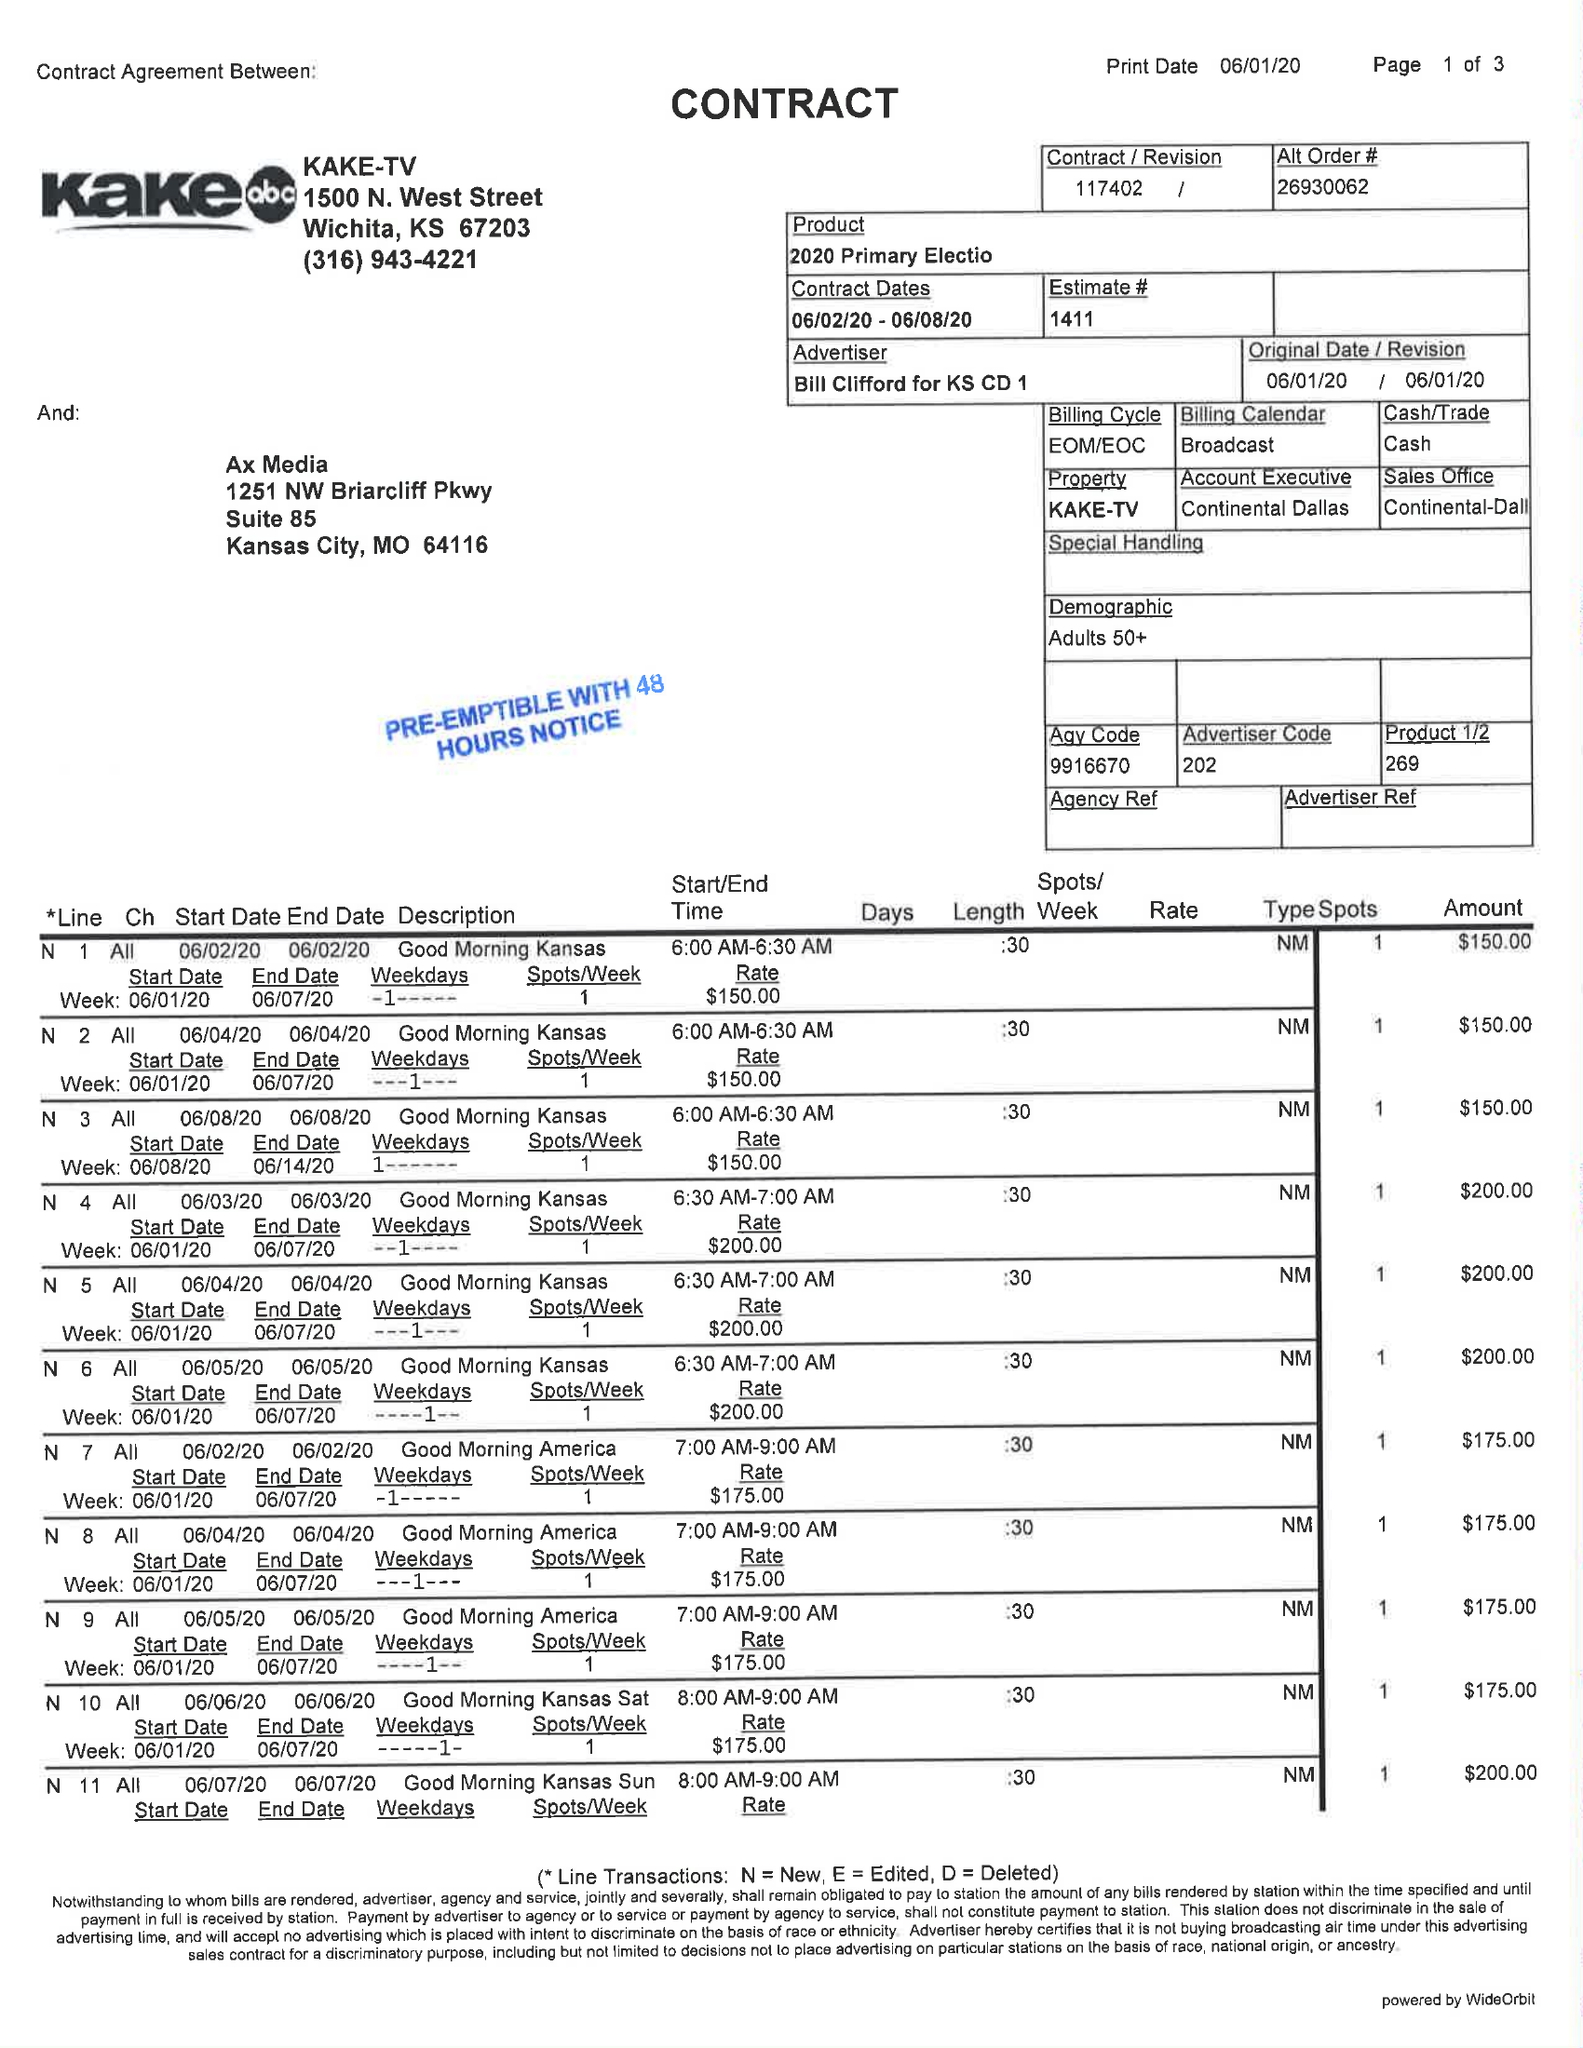What is the value for the gross_amount?
Answer the question using a single word or phrase. 595000.00 